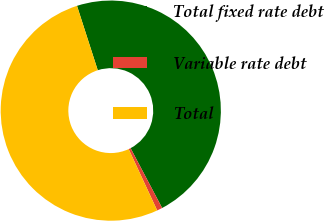<chart> <loc_0><loc_0><loc_500><loc_500><pie_chart><fcel>Total fixed rate debt<fcel>Variable rate debt<fcel>Total<nl><fcel>47.24%<fcel>0.8%<fcel>51.96%<nl></chart> 